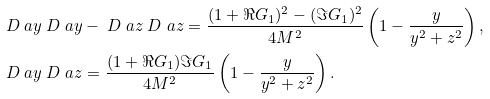Convert formula to latex. <formula><loc_0><loc_0><loc_500><loc_500>& \ D _ { \ } a y \ D ^ { \ } a y - \ D _ { \ } a z \ D ^ { \ } a z = \frac { ( 1 + \Re G _ { 1 } ) ^ { 2 } - ( \Im G _ { 1 } ) ^ { 2 } } { 4 M ^ { 2 } } \left ( 1 - \frac { y } { y ^ { 2 } + z ^ { 2 } } \right ) , \\ & \ D _ { \ } a y \ D ^ { \ } a z = \frac { ( 1 + \Re G _ { 1 } ) \Im G _ { 1 } } { 4 M ^ { 2 } } \left ( 1 - \frac { y } { y ^ { 2 } + z ^ { 2 } } \right ) .</formula> 